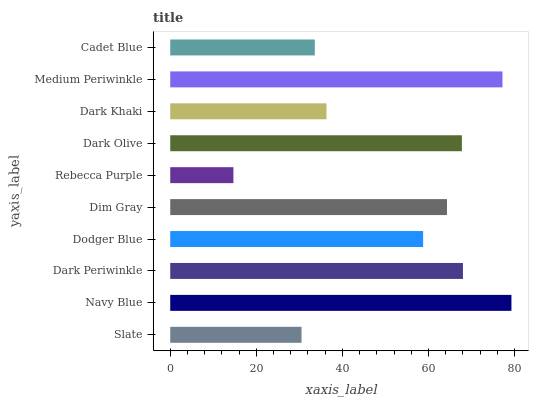Is Rebecca Purple the minimum?
Answer yes or no. Yes. Is Navy Blue the maximum?
Answer yes or no. Yes. Is Dark Periwinkle the minimum?
Answer yes or no. No. Is Dark Periwinkle the maximum?
Answer yes or no. No. Is Navy Blue greater than Dark Periwinkle?
Answer yes or no. Yes. Is Dark Periwinkle less than Navy Blue?
Answer yes or no. Yes. Is Dark Periwinkle greater than Navy Blue?
Answer yes or no. No. Is Navy Blue less than Dark Periwinkle?
Answer yes or no. No. Is Dim Gray the high median?
Answer yes or no. Yes. Is Dodger Blue the low median?
Answer yes or no. Yes. Is Dark Khaki the high median?
Answer yes or no. No. Is Navy Blue the low median?
Answer yes or no. No. 